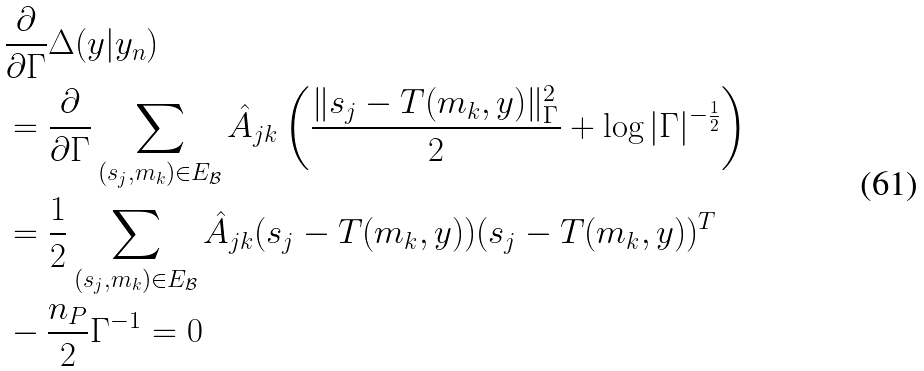<formula> <loc_0><loc_0><loc_500><loc_500>& \frac { \partial } { \partial \Gamma } \Delta ( y | y _ { n } ) \\ & = \frac { \partial } { \partial \Gamma } \sum _ { ( s _ { j } , m _ { k } ) \in E _ { \mathcal { B } } } \hat { A } _ { j k } \left ( \frac { \| s _ { j } - T ( m _ { k } , y ) \| _ { \Gamma } ^ { 2 } } { 2 } + \log | \Gamma | ^ { - \frac { 1 } { 2 } } \right ) \\ & = \frac { 1 } { 2 } \sum _ { ( s _ { j } , m _ { k } ) \in E _ { \mathcal { B } } } { \hat { A } _ { j k } ( s _ { j } - T ( m _ { k } , y ) ) ( s _ { j } - T ( m _ { k } , y ) ) ^ { T } } \\ & - \frac { n _ { P } } { 2 } \Gamma ^ { - 1 } = 0</formula> 